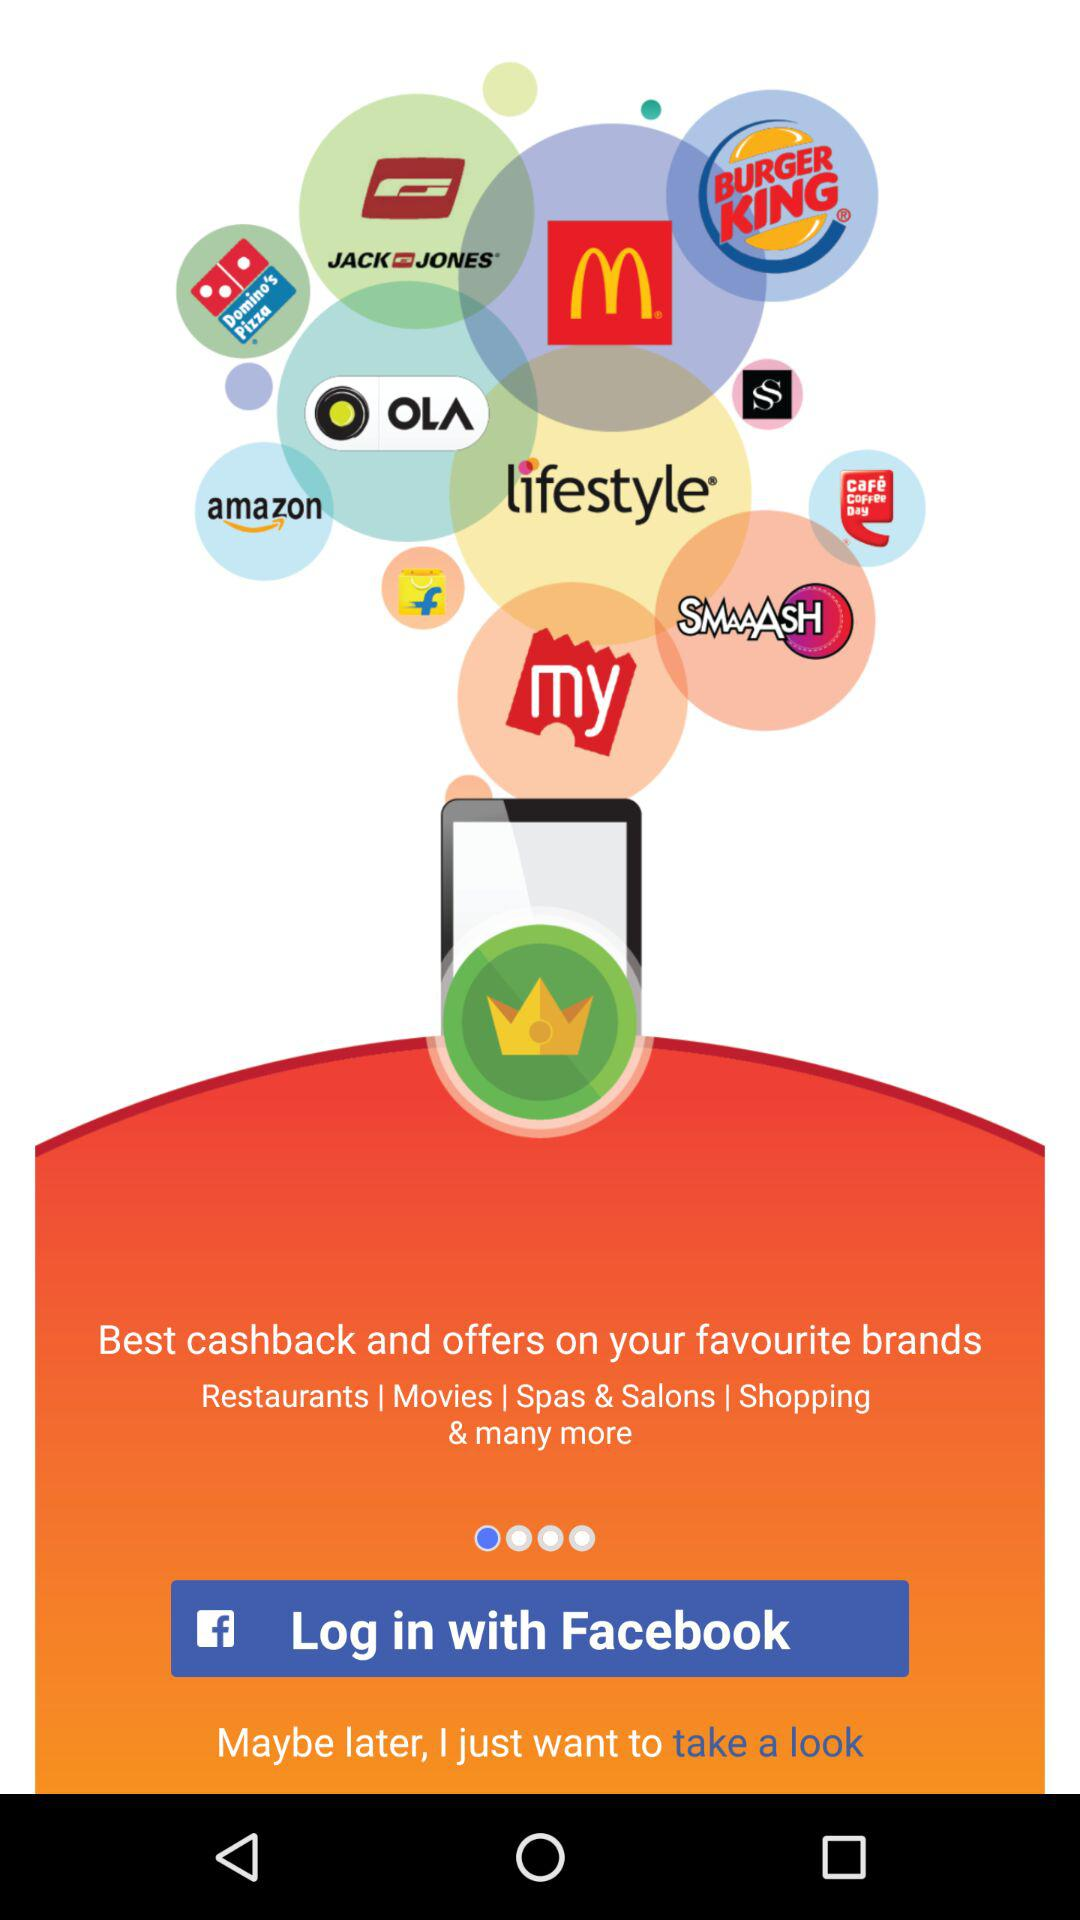Through which application can we log in? You can log in through "Facebook". 